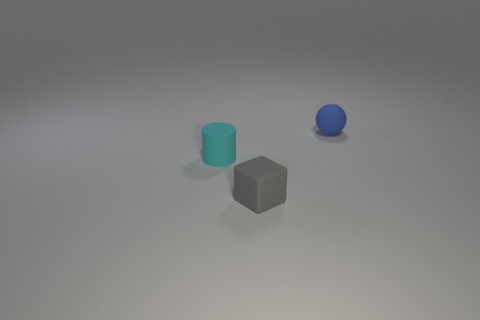Do the tiny thing that is on the right side of the small rubber cube and the cyan matte thing have the same shape?
Keep it short and to the point. No. Are there fewer tiny things in front of the tiny matte cylinder than purple balls?
Your answer should be compact. No. Is there a small cube that has the same color as the small rubber cylinder?
Provide a short and direct response. No. Do the tiny cyan object and the thing in front of the small cyan rubber cylinder have the same shape?
Keep it short and to the point. No. Are there any small balls that have the same material as the cyan cylinder?
Your answer should be compact. Yes. Are there any small gray objects to the right of the rubber object behind the tiny matte thing that is on the left side of the tiny gray matte thing?
Your response must be concise. No. What number of other objects are the same shape as the small cyan object?
Offer a very short reply. 0. What color is the object in front of the small rubber object that is left of the small thing in front of the small cylinder?
Your answer should be very brief. Gray. How many brown metal blocks are there?
Ensure brevity in your answer.  0. How many tiny objects are blue matte spheres or yellow metallic balls?
Offer a terse response. 1. 